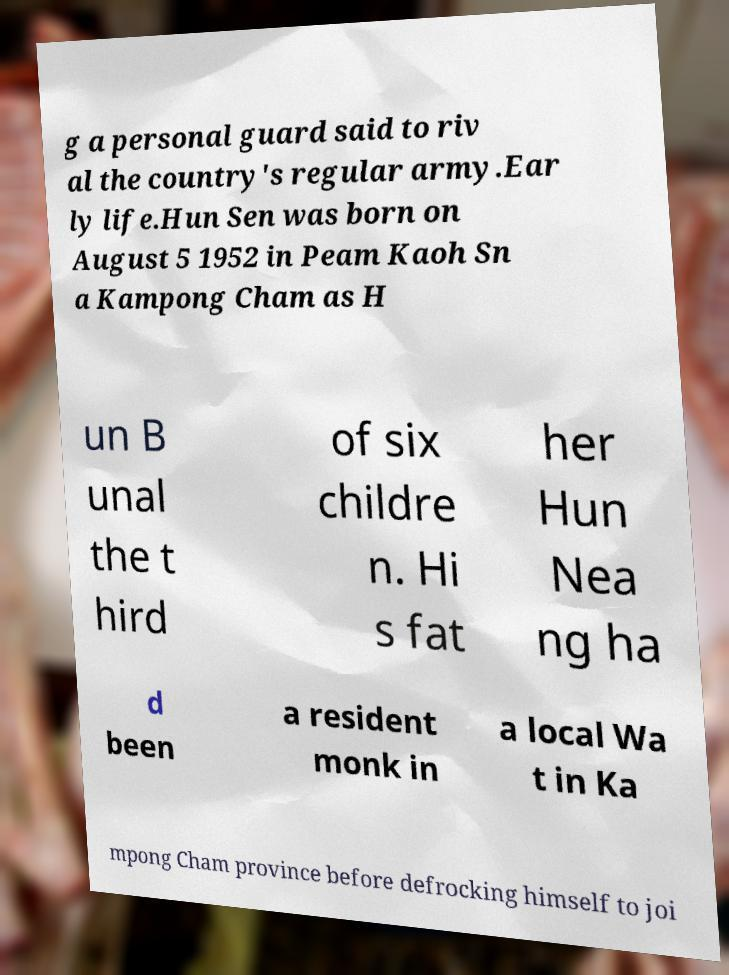What messages or text are displayed in this image? I need them in a readable, typed format. g a personal guard said to riv al the country's regular army.Ear ly life.Hun Sen was born on August 5 1952 in Peam Kaoh Sn a Kampong Cham as H un B unal the t hird of six childre n. Hi s fat her Hun Nea ng ha d been a resident monk in a local Wa t in Ka mpong Cham province before defrocking himself to joi 